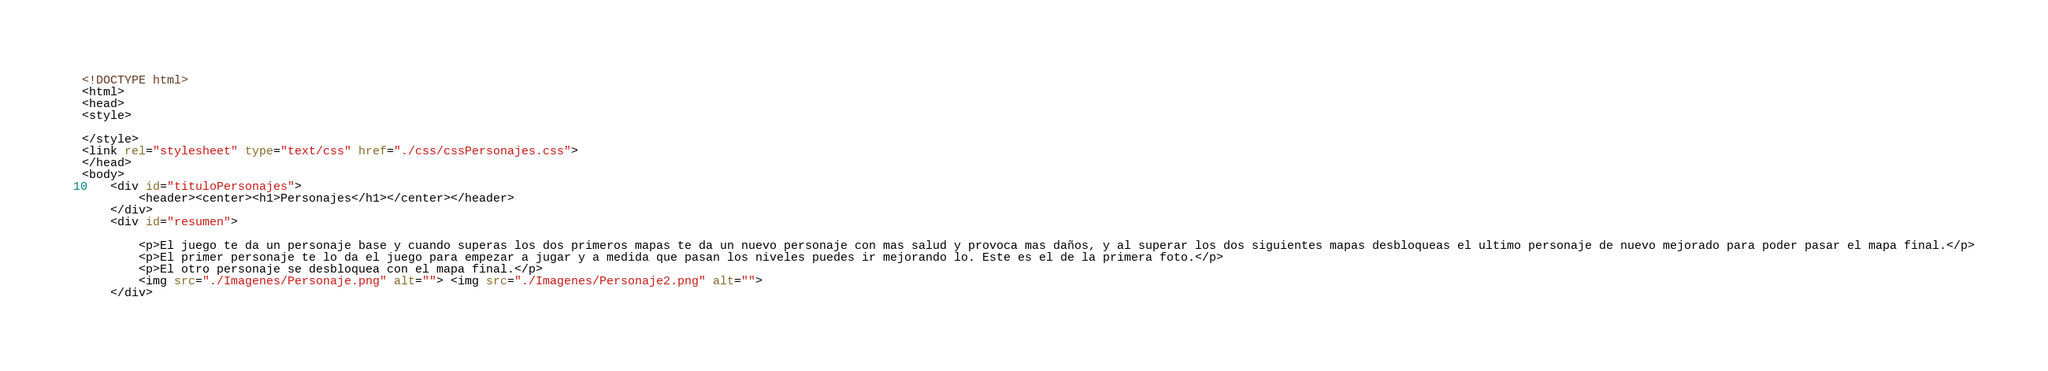Convert code to text. <code><loc_0><loc_0><loc_500><loc_500><_HTML_><!DOCTYPE html>
<html>
<head>
<style>
   
</style>
<link rel="stylesheet" type="text/css" href="./css/cssPersonajes.css">
</head>
<body>
    <div id="tituloPersonajes">
        <header><center><h1>Personajes</h1></center></header>
    </div>
    <div id="resumen">
       
        <p>El juego te da un personaje base y cuando superas los dos primeros mapas te da un nuevo personaje con mas salud y provoca mas daños, y al superar los dos siguientes mapas desbloqueas el ultimo personaje de nuevo mejorado para poder pasar el mapa final.</p>
        <p>El primer personaje te lo da el juego para empezar a jugar y a medida que pasan los niveles puedes ir mejorando lo. Este es el de la primera foto.</p>
        <p>El otro personaje se desbloquea con el mapa final.</p>
        <img src="./Imagenes/Personaje.png" alt=""> <img src="./Imagenes/Personaje2.png" alt="">
    </div>
</code> 